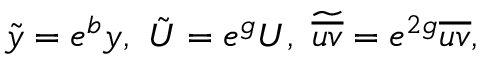Convert formula to latex. <formula><loc_0><loc_0><loc_500><loc_500>\tilde { y } = e ^ { b } y , \ \tilde { U } = e ^ { g } U , \ \widetilde { \overline { u v } } = e ^ { 2 g } \overline { u v } ,</formula> 